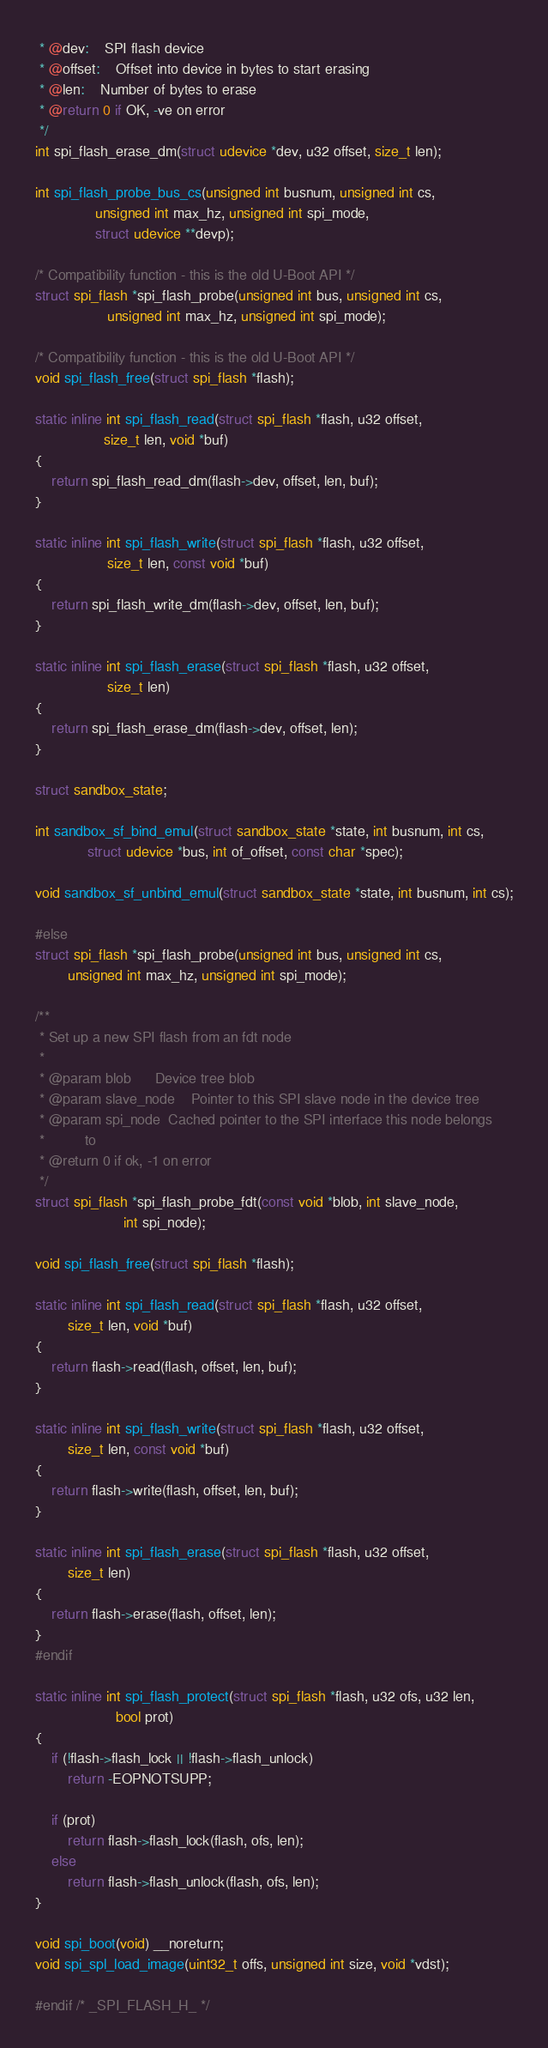Convert code to text. <code><loc_0><loc_0><loc_500><loc_500><_C_> * @dev:	SPI flash device
 * @offset:	Offset into device in bytes to start erasing
 * @len:	Number of bytes to erase
 * @return 0 if OK, -ve on error
 */
int spi_flash_erase_dm(struct udevice *dev, u32 offset, size_t len);

int spi_flash_probe_bus_cs(unsigned int busnum, unsigned int cs,
			   unsigned int max_hz, unsigned int spi_mode,
			   struct udevice **devp);

/* Compatibility function - this is the old U-Boot API */
struct spi_flash *spi_flash_probe(unsigned int bus, unsigned int cs,
				  unsigned int max_hz, unsigned int spi_mode);

/* Compatibility function - this is the old U-Boot API */
void spi_flash_free(struct spi_flash *flash);

static inline int spi_flash_read(struct spi_flash *flash, u32 offset,
				 size_t len, void *buf)
{
	return spi_flash_read_dm(flash->dev, offset, len, buf);
}

static inline int spi_flash_write(struct spi_flash *flash, u32 offset,
				  size_t len, const void *buf)
{
	return spi_flash_write_dm(flash->dev, offset, len, buf);
}

static inline int spi_flash_erase(struct spi_flash *flash, u32 offset,
				  size_t len)
{
	return spi_flash_erase_dm(flash->dev, offset, len);
}

struct sandbox_state;

int sandbox_sf_bind_emul(struct sandbox_state *state, int busnum, int cs,
			 struct udevice *bus, int of_offset, const char *spec);

void sandbox_sf_unbind_emul(struct sandbox_state *state, int busnum, int cs);

#else
struct spi_flash *spi_flash_probe(unsigned int bus, unsigned int cs,
		unsigned int max_hz, unsigned int spi_mode);

/**
 * Set up a new SPI flash from an fdt node
 *
 * @param blob		Device tree blob
 * @param slave_node	Pointer to this SPI slave node in the device tree
 * @param spi_node	Cached pointer to the SPI interface this node belongs
 *			to
 * @return 0 if ok, -1 on error
 */
struct spi_flash *spi_flash_probe_fdt(const void *blob, int slave_node,
				      int spi_node);

void spi_flash_free(struct spi_flash *flash);

static inline int spi_flash_read(struct spi_flash *flash, u32 offset,
		size_t len, void *buf)
{
	return flash->read(flash, offset, len, buf);
}

static inline int spi_flash_write(struct spi_flash *flash, u32 offset,
		size_t len, const void *buf)
{
	return flash->write(flash, offset, len, buf);
}

static inline int spi_flash_erase(struct spi_flash *flash, u32 offset,
		size_t len)
{
	return flash->erase(flash, offset, len);
}
#endif

static inline int spi_flash_protect(struct spi_flash *flash, u32 ofs, u32 len,
					bool prot)
{
	if (!flash->flash_lock || !flash->flash_unlock)
		return -EOPNOTSUPP;

	if (prot)
		return flash->flash_lock(flash, ofs, len);
	else
		return flash->flash_unlock(flash, ofs, len);
}

void spi_boot(void) __noreturn;
void spi_spl_load_image(uint32_t offs, unsigned int size, void *vdst);

#endif /* _SPI_FLASH_H_ */
</code> 